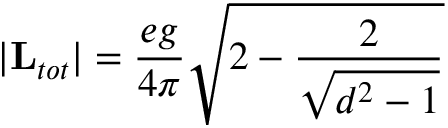<formula> <loc_0><loc_0><loc_500><loc_500>| { L } _ { t o t } | = { \frac { e g } { 4 \pi } } \sqrt { 2 - { \frac { 2 } { \sqrt { d ^ { 2 } - 1 } } } }</formula> 